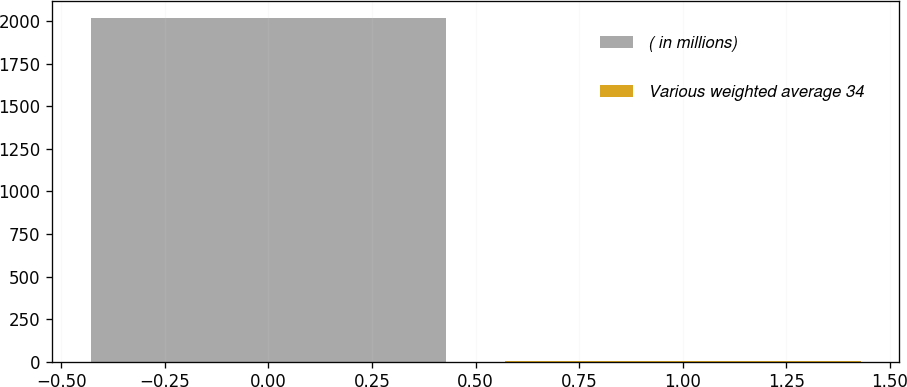<chart> <loc_0><loc_0><loc_500><loc_500><bar_chart><fcel>( in millions)<fcel>Various weighted average 34<nl><fcel>2018<fcel>4<nl></chart> 